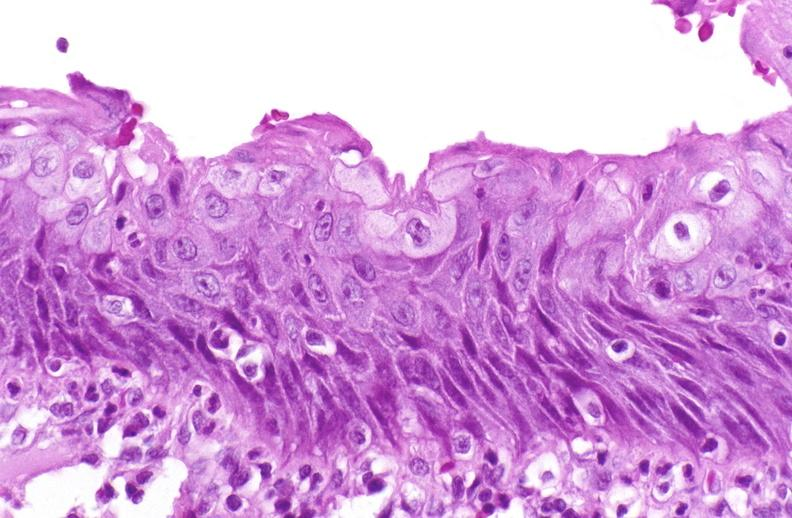why does this image show squamous metaplasia, renal pelvis?
Answer the question using a single word or phrase. Due to nephrolithiasis 